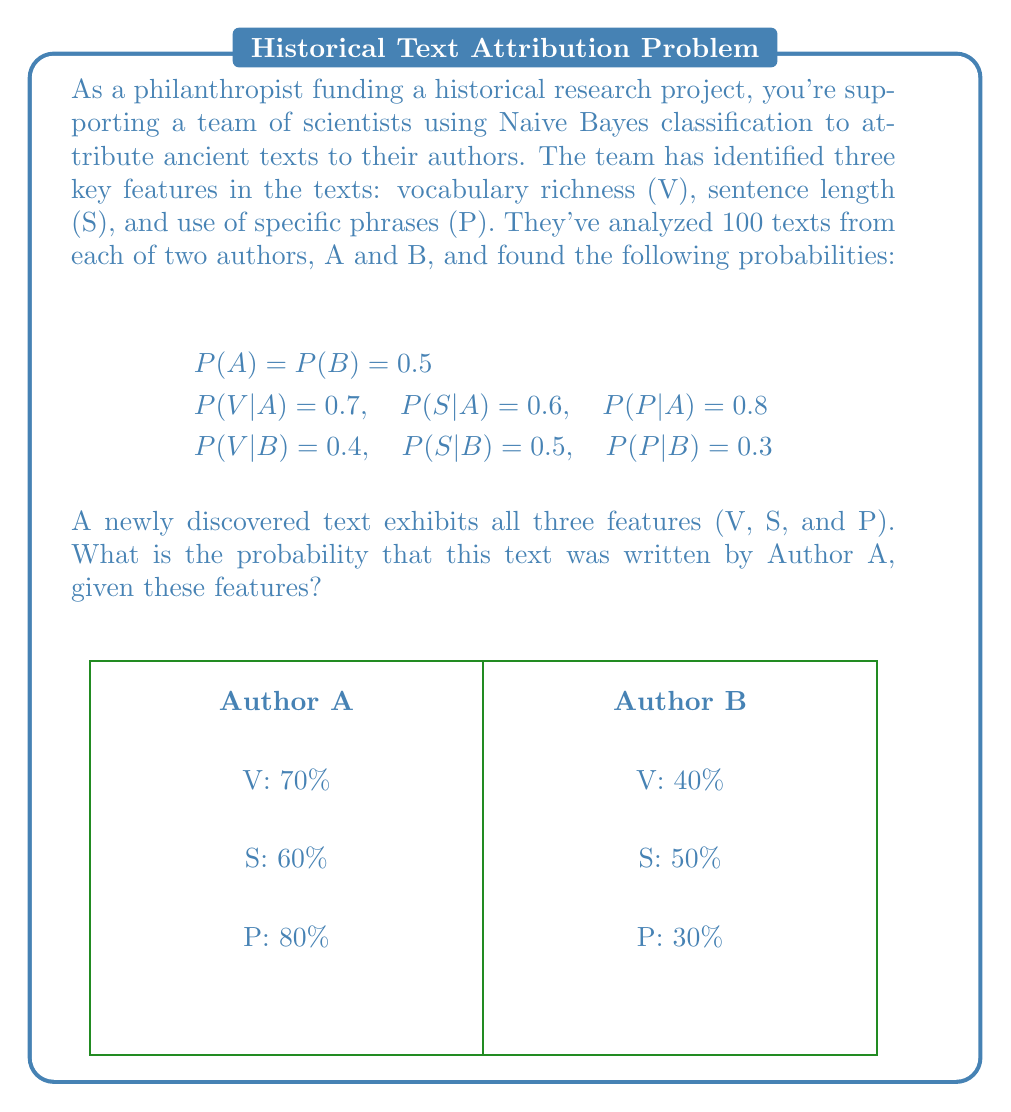Can you answer this question? To solve this problem, we'll use Naive Bayes classification. The goal is to calculate $P(A|V,S,P)$, the probability that the text was written by Author A given the presence of all three features.

Step 1: Apply Bayes' theorem
$$P(A|V,S,P) = \frac{P(V,S,P|A) \cdot P(A)}{P(V,S,P)}$$

Step 2: Expand the numerator using the naive assumption of feature independence
$$P(A|V,S,P) = \frac{P(V|A) \cdot P(S|A) \cdot P(P|A) \cdot P(A)}{P(V,S,P)}$$

Step 3: Calculate the numerator
$$\text{Numerator} = 0.7 \cdot 0.6 \cdot 0.8 \cdot 0.5 = 0.168$$

Step 4: Calculate $P(V,S,P)$ using the law of total probability
$$P(V,S,P) = P(V,S,P|A) \cdot P(A) + P(V,S,P|B) \cdot P(B)$$
$$= (0.7 \cdot 0.6 \cdot 0.8 \cdot 0.5) + (0.4 \cdot 0.5 \cdot 0.3 \cdot 0.5)$$
$$= 0.168 + 0.03 = 0.198$$

Step 5: Calculate the final probability
$$P(A|V,S,P) = \frac{0.168}{0.198} \approx 0.8485$$

Therefore, the probability that the text was written by Author A, given the presence of all three features, is approximately 0.8485 or 84.85%.
Answer: 0.8485 